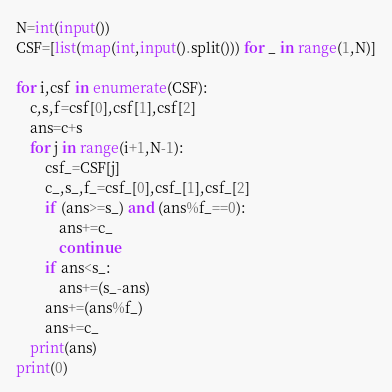Convert code to text. <code><loc_0><loc_0><loc_500><loc_500><_Python_>N=int(input())
CSF=[list(map(int,input().split())) for _ in range(1,N)]

for i,csf in enumerate(CSF):
    c,s,f=csf[0],csf[1],csf[2]
    ans=c+s
    for j in range(i+1,N-1):
        csf_=CSF[j]
        c_,s_,f_=csf_[0],csf_[1],csf_[2]
        if (ans>=s_) and (ans%f_==0):
            ans+=c_
            continue
        if ans<s_:
            ans+=(s_-ans)
        ans+=(ans%f_)
        ans+=c_
    print(ans)
print(0)</code> 